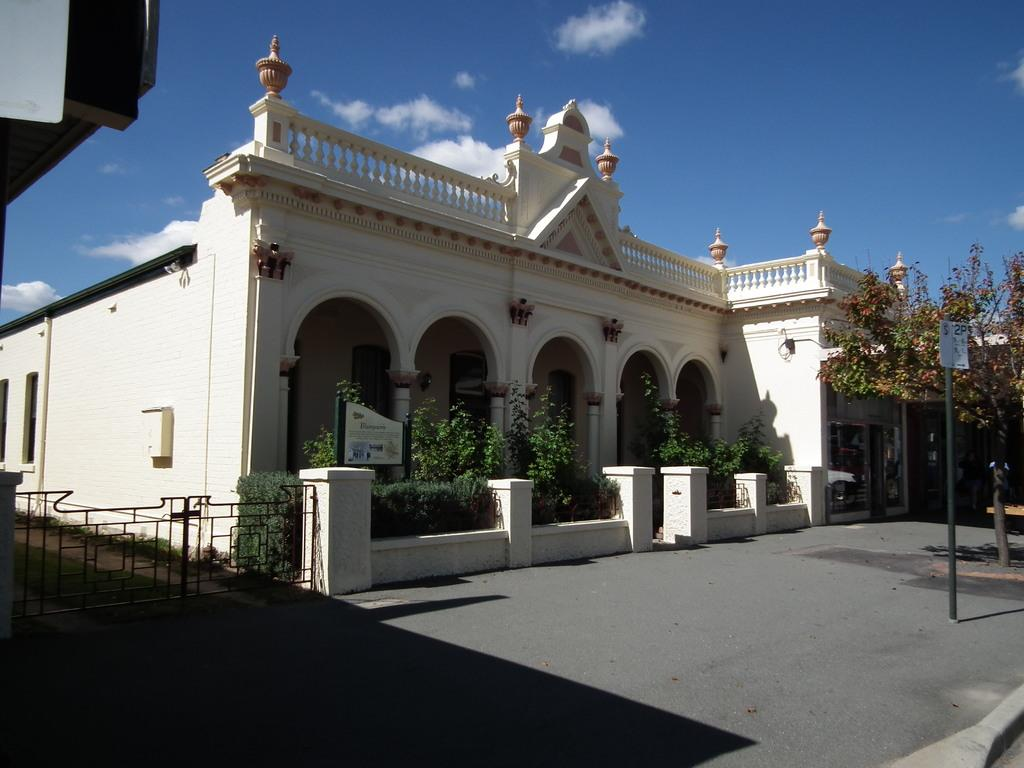What type of structure is visible in the image? There is a building in the image. What architectural feature can be seen in the image? There are arches in the image. What type of vegetation is present in the image? There are trees in the image. What objects are present in the image that might be used for support or signage? There are poles in the image. What might be a typo in the provided facts? The fact mentions "pants" in the image, which is likely a typo for "plants." What can be seen in the background of the image? There is a fence in the background of the image. What part of the natural environment is visible in the image? The sky is visible in the image. How does the boot help in the comparison of the two buildings in the image? There is no boot present in the image, and no comparison of two buildings is mentioned. 